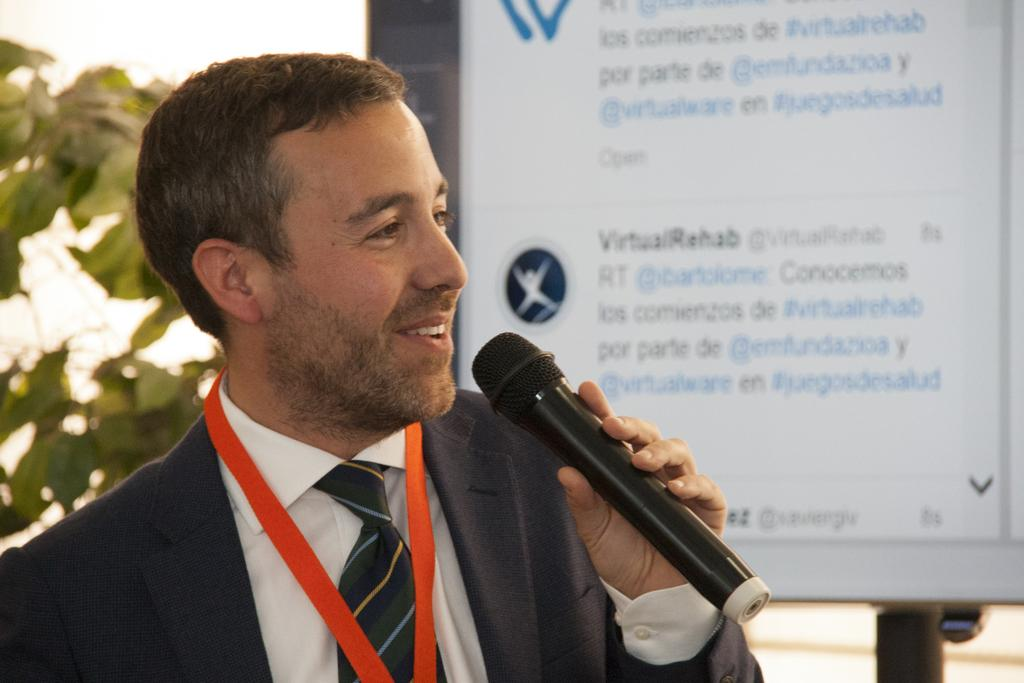What can be seen hanging in the image? There is a banner in the image. What is the man in the image doing? The man is holding a microphone in the image. What type of chicken is being cooked in the oven in the image? There is no oven or chicken present in the image. Can you describe the romantic gesture between the man and woman in the image? There is no woman or romantic gesture depicted in the image; it only features a man holding a microphone and a banner. 